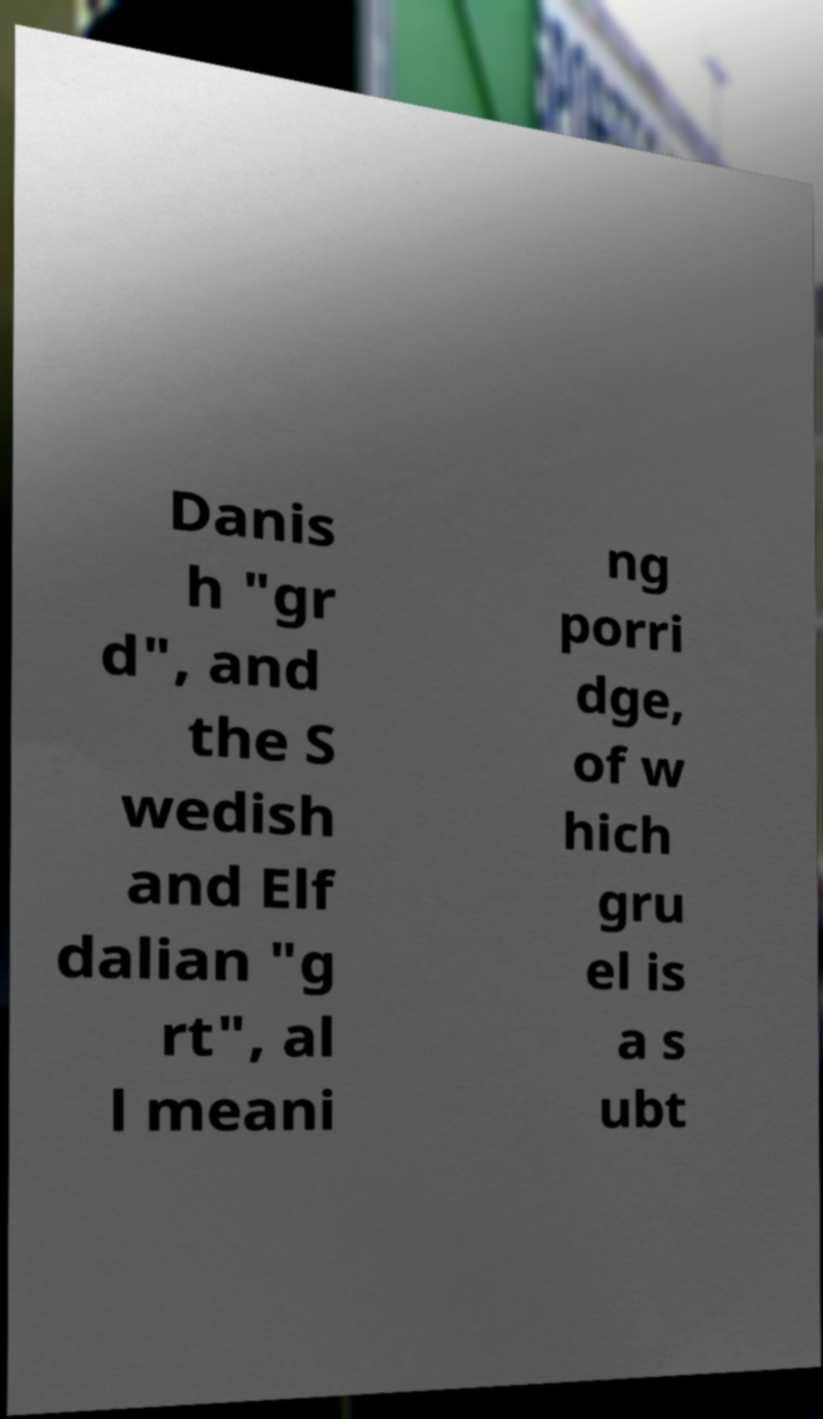Can you read and provide the text displayed in the image?This photo seems to have some interesting text. Can you extract and type it out for me? Danis h "gr d", and the S wedish and Elf dalian "g rt", al l meani ng porri dge, of w hich gru el is a s ubt 